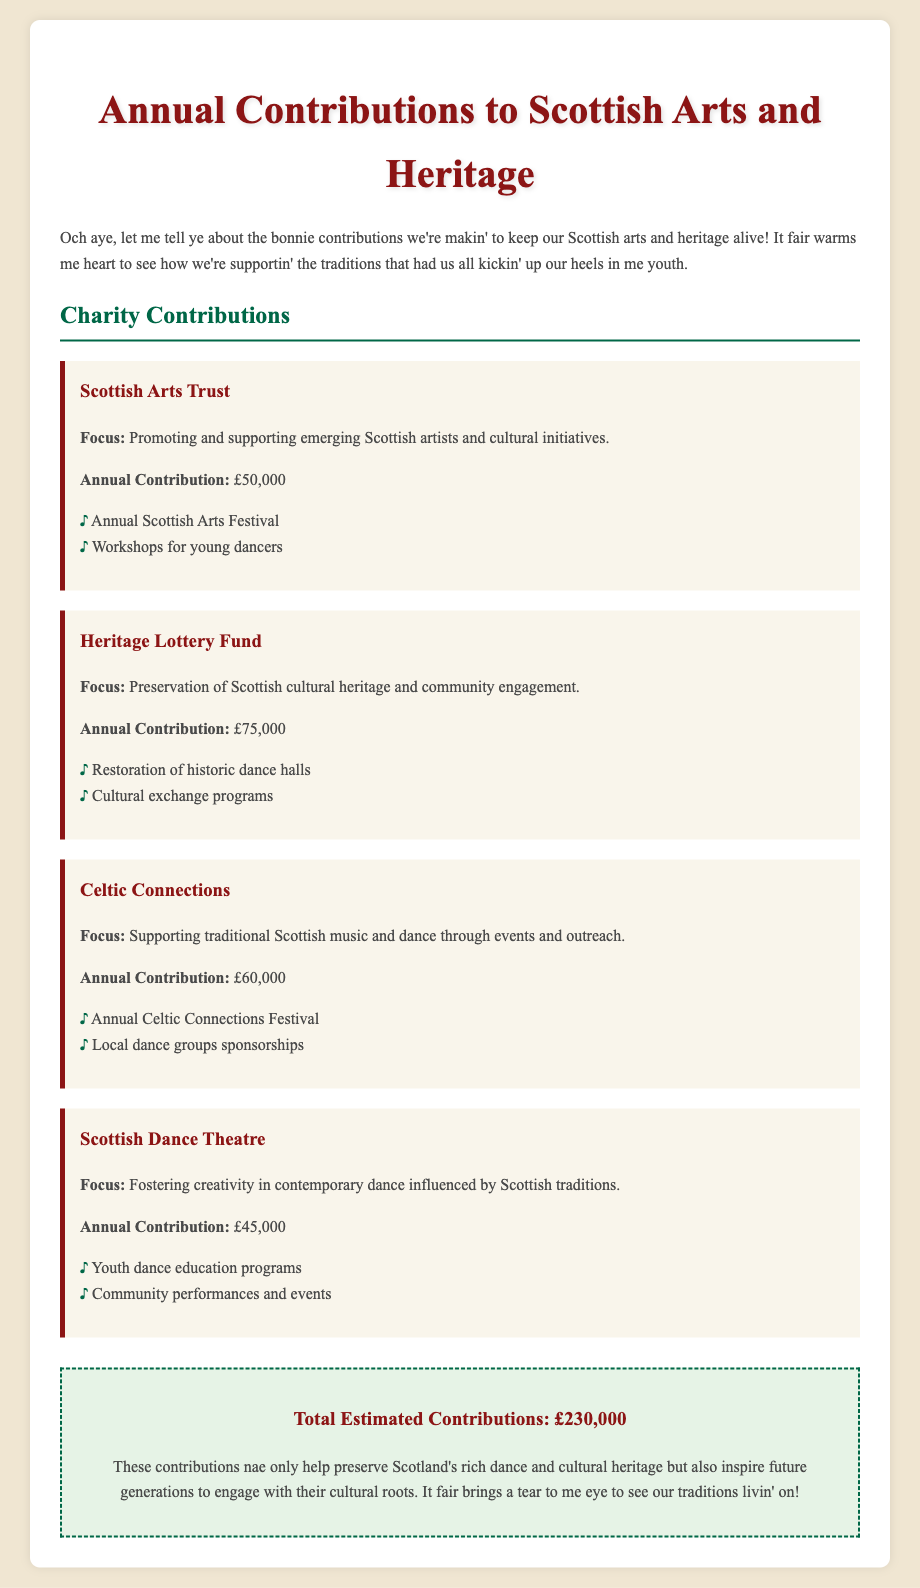What is the total estimated contribution? The total estimated contributions are listed in the summary section, which sums the contributions from all charities.
Answer: £230,000 How much does the Scottish Arts Trust receive annually? The annual contribution for the Scottish Arts Trust is specifically mentioned in the document.
Answer: £50,000 Which charity focuses on restoring historic dance halls? The document states that the Heritage Lottery Fund focuses on the preservation of Scottish cultural heritage, which includes restoring historic dance halls.
Answer: Heritage Lottery Fund What project does Celtic Connections support? One of the projects mentioned for Celtic Connections is the Annual Celtic Connections Festival.
Answer: Annual Celtic Connections Festival How much does the Scottish Dance Theatre contribute annually? The annual contribution for the Scottish Dance Theatre is provided in the document.
Answer: £45,000 Which charity supports workshops for young dancers? The document indicates that the Scottish Arts Trust supports workshops for young dancers within its initiatives.
Answer: Scottish Arts Trust What is the focus of the Heritage Lottery Fund? The focus of the Heritage Lottery Fund is summarized in the document, which highlights its aim for preservation and community engagement.
Answer: Preservation of Scottish cultural heritage and community engagement How much does Celtic Connections receive annually? The annual contribution for Celtic Connections is specified in the document.
Answer: £60,000 